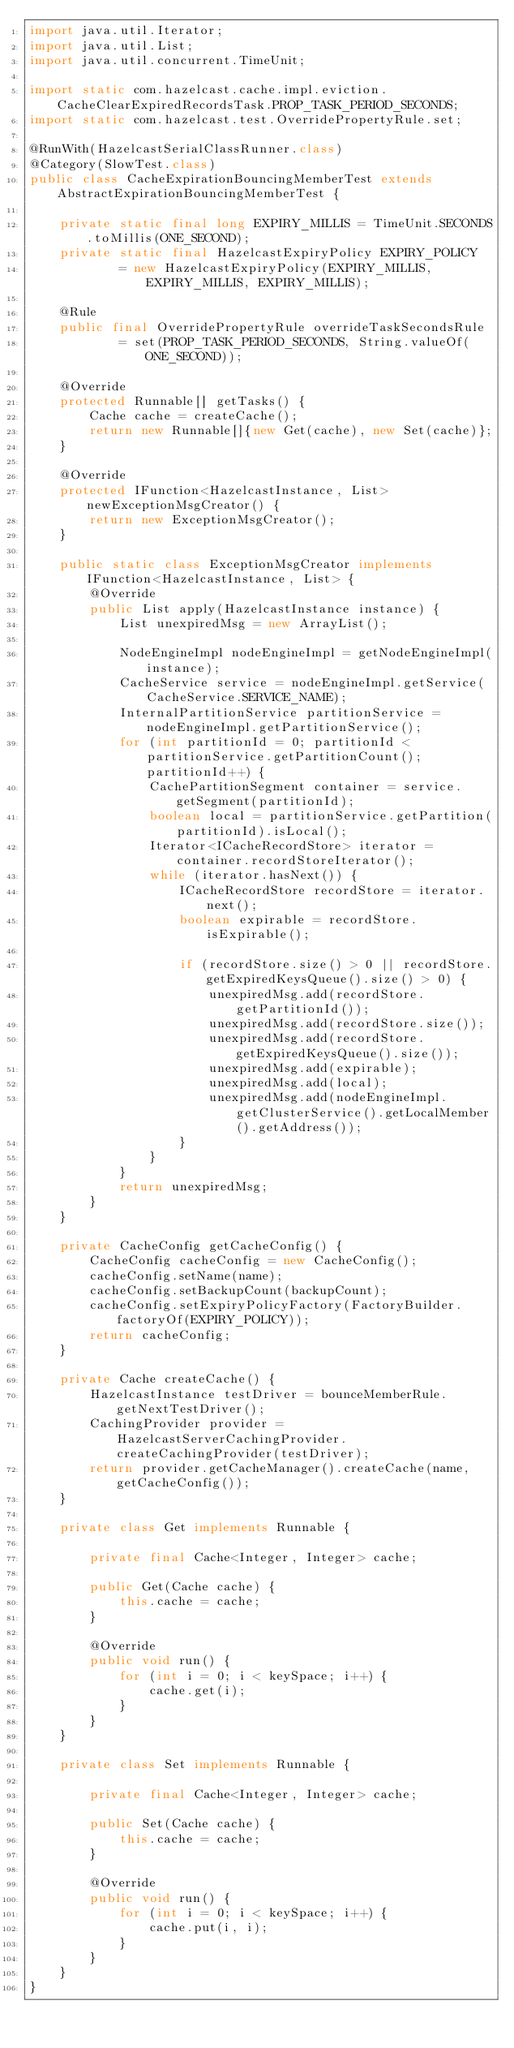Convert code to text. <code><loc_0><loc_0><loc_500><loc_500><_Java_>import java.util.Iterator;
import java.util.List;
import java.util.concurrent.TimeUnit;

import static com.hazelcast.cache.impl.eviction.CacheClearExpiredRecordsTask.PROP_TASK_PERIOD_SECONDS;
import static com.hazelcast.test.OverridePropertyRule.set;

@RunWith(HazelcastSerialClassRunner.class)
@Category(SlowTest.class)
public class CacheExpirationBouncingMemberTest extends AbstractExpirationBouncingMemberTest {

    private static final long EXPIRY_MILLIS = TimeUnit.SECONDS.toMillis(ONE_SECOND);
    private static final HazelcastExpiryPolicy EXPIRY_POLICY
            = new HazelcastExpiryPolicy(EXPIRY_MILLIS, EXPIRY_MILLIS, EXPIRY_MILLIS);

    @Rule
    public final OverridePropertyRule overrideTaskSecondsRule
            = set(PROP_TASK_PERIOD_SECONDS, String.valueOf(ONE_SECOND));

    @Override
    protected Runnable[] getTasks() {
        Cache cache = createCache();
        return new Runnable[]{new Get(cache), new Set(cache)};
    }

    @Override
    protected IFunction<HazelcastInstance, List> newExceptionMsgCreator() {
        return new ExceptionMsgCreator();
    }

    public static class ExceptionMsgCreator implements IFunction<HazelcastInstance, List> {
        @Override
        public List apply(HazelcastInstance instance) {
            List unexpiredMsg = new ArrayList();

            NodeEngineImpl nodeEngineImpl = getNodeEngineImpl(instance);
            CacheService service = nodeEngineImpl.getService(CacheService.SERVICE_NAME);
            InternalPartitionService partitionService = nodeEngineImpl.getPartitionService();
            for (int partitionId = 0; partitionId < partitionService.getPartitionCount(); partitionId++) {
                CachePartitionSegment container = service.getSegment(partitionId);
                boolean local = partitionService.getPartition(partitionId).isLocal();
                Iterator<ICacheRecordStore> iterator = container.recordStoreIterator();
                while (iterator.hasNext()) {
                    ICacheRecordStore recordStore = iterator.next();
                    boolean expirable = recordStore.isExpirable();

                    if (recordStore.size() > 0 || recordStore.getExpiredKeysQueue().size() > 0) {
                        unexpiredMsg.add(recordStore.getPartitionId());
                        unexpiredMsg.add(recordStore.size());
                        unexpiredMsg.add(recordStore.getExpiredKeysQueue().size());
                        unexpiredMsg.add(expirable);
                        unexpiredMsg.add(local);
                        unexpiredMsg.add(nodeEngineImpl.getClusterService().getLocalMember().getAddress());
                    }
                }
            }
            return unexpiredMsg;
        }
    }

    private CacheConfig getCacheConfig() {
        CacheConfig cacheConfig = new CacheConfig();
        cacheConfig.setName(name);
        cacheConfig.setBackupCount(backupCount);
        cacheConfig.setExpiryPolicyFactory(FactoryBuilder.factoryOf(EXPIRY_POLICY));
        return cacheConfig;
    }

    private Cache createCache() {
        HazelcastInstance testDriver = bounceMemberRule.getNextTestDriver();
        CachingProvider provider = HazelcastServerCachingProvider.createCachingProvider(testDriver);
        return provider.getCacheManager().createCache(name, getCacheConfig());
    }

    private class Get implements Runnable {

        private final Cache<Integer, Integer> cache;

        public Get(Cache cache) {
            this.cache = cache;
        }

        @Override
        public void run() {
            for (int i = 0; i < keySpace; i++) {
                cache.get(i);
            }
        }
    }

    private class Set implements Runnable {

        private final Cache<Integer, Integer> cache;

        public Set(Cache cache) {
            this.cache = cache;
        }

        @Override
        public void run() {
            for (int i = 0; i < keySpace; i++) {
                cache.put(i, i);
            }
        }
    }
}
</code> 